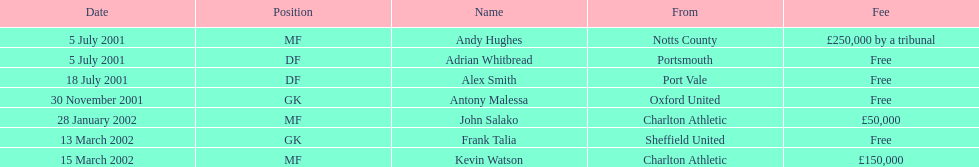Are there at least 2 nationalities on the chart? Yes. Could you help me parse every detail presented in this table? {'header': ['Date', 'Position', 'Name', 'From', 'Fee'], 'rows': [['5 July 2001', 'MF', 'Andy Hughes', 'Notts County', '£250,000 by a tribunal'], ['5 July 2001', 'DF', 'Adrian Whitbread', 'Portsmouth', 'Free'], ['18 July 2001', 'DF', 'Alex Smith', 'Port Vale', 'Free'], ['30 November 2001', 'GK', 'Antony Malessa', 'Oxford United', 'Free'], ['28 January 2002', 'MF', 'John Salako', 'Charlton Athletic', '£50,000'], ['13 March 2002', 'GK', 'Frank Talia', 'Sheffield United', 'Free'], ['15 March 2002', 'MF', 'Kevin Watson', 'Charlton Athletic', '£150,000']]} 